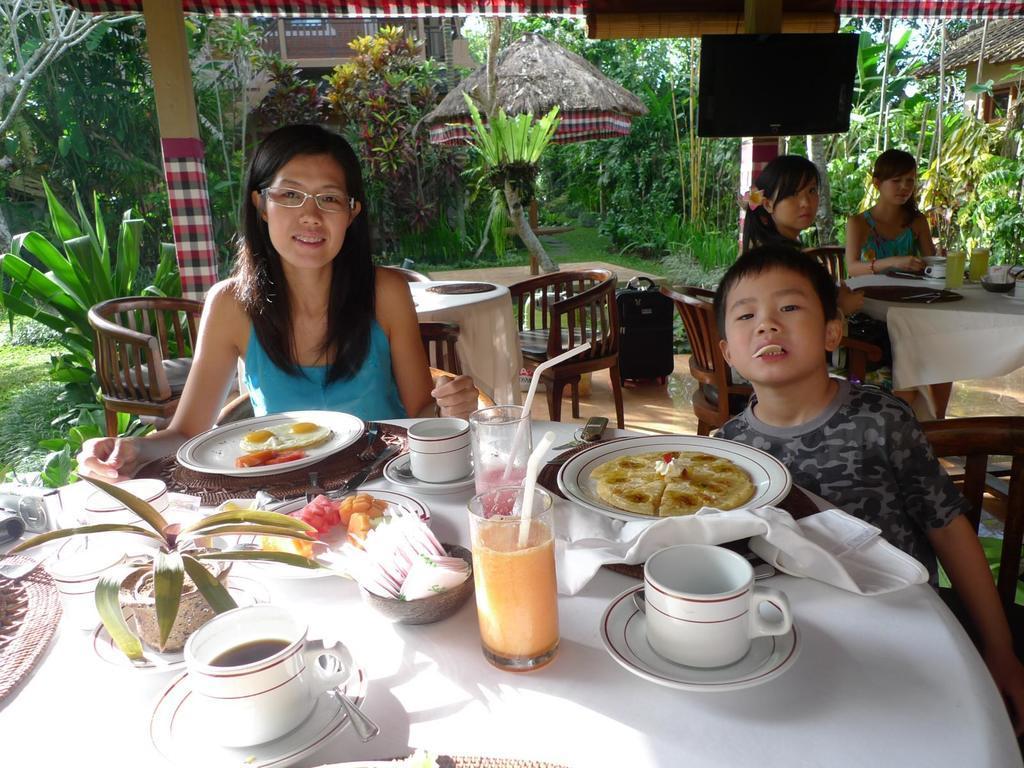In one or two sentences, can you explain what this image depicts? In this image i can see few persons sitting on chairs in front of a dining table, On the table i can see a cup, a plant, few bowls, few plates and some food items. In the background i can see few buildings , a hut, few trees and the sky. 